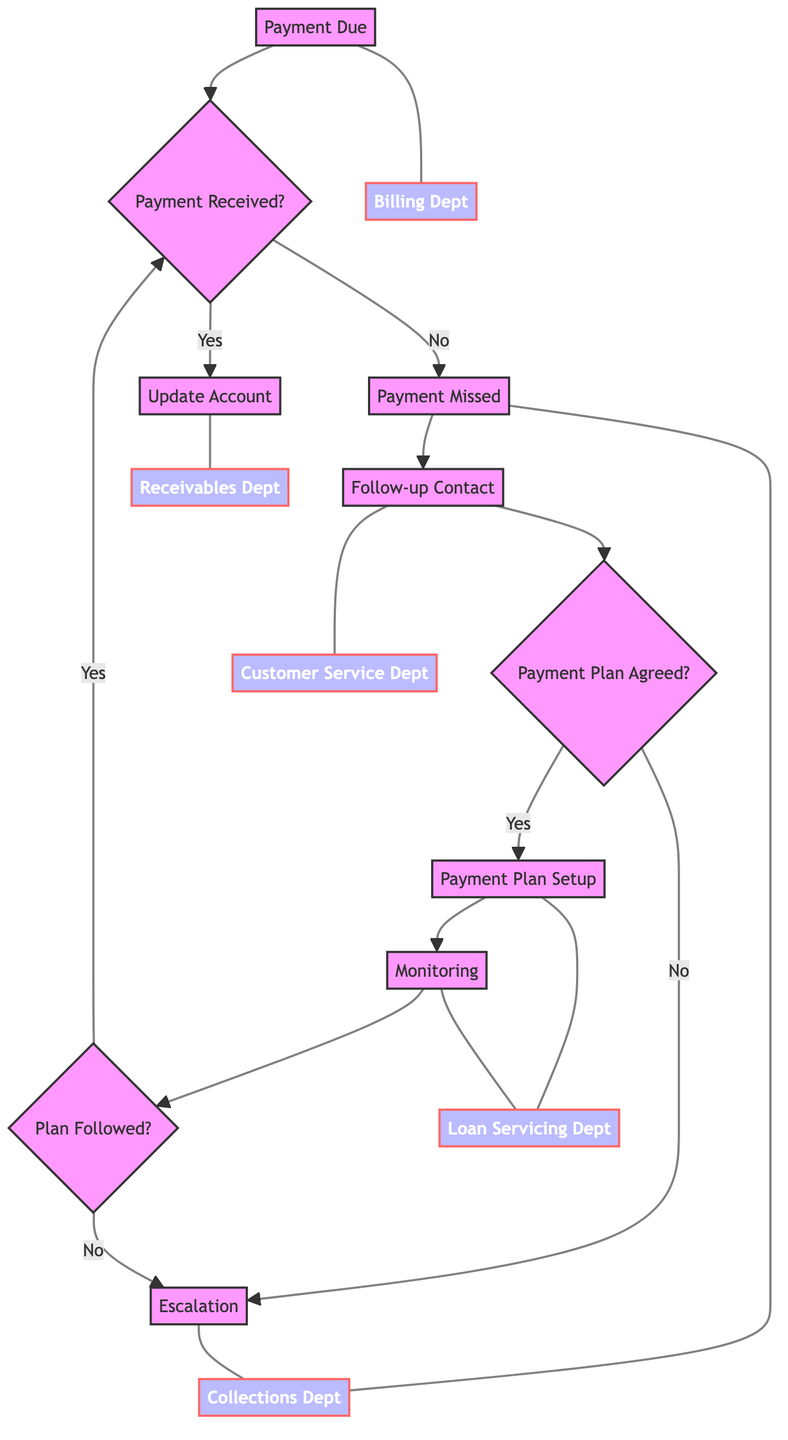What is the first step in the process? The first step in the process is labeled as "Payment Due," which indicates that the customer's mortgage payment is due.
Answer: Payment Due Which department is responsible for generating the monthly statement? The "Payment Due" step is associated with the Billing Department, which is responsible for generating the monthly statement.
Answer: Billing Department How many total steps are there in this flow chart? The flow chart consists of seven steps, starting from "Payment Due" and ending at "Escalation."
Answer: Seven What happens after a payment is missed? After a payment is missed, the next step is "Follow-up Contact," where the customer service department contacts the customer regarding the missed payment.
Answer: Follow-up Contact What occurs if the customer agrees to a payment plan? If the customer agrees to a payment plan, the next step is "Payment Plan Setup," where the payment plan details are drafted and agreed upon with the customer.
Answer: Payment Plan Setup What action is taken if the customer fails to adhere to their payment plan? If the customer fails to adhere to the payment plan, the process moves on to "Escalation," where procedures for foreclosure may be initiated and the legal team is notified.
Answer: Escalation Which department sends the payment confirmation? The "Payment Received" step is managed by the Receivables Department, which includes the action of sending the payment confirmation to the customer.
Answer: Receivables Department What indicates that a customer is in a 'Delinquent' status? The 'Delinquent' status is indicated after the action taken during the "Payment Missed" step, which updates the customer's payment status to delinquent.
Answer: Delinquent How is customer adherence to the payment plan monitored? Customer adherence is monitored in the "Monitoring" step, where compliance with the payment plan is tracked and reminders for upcoming payments are sent.
Answer: Monitoring 